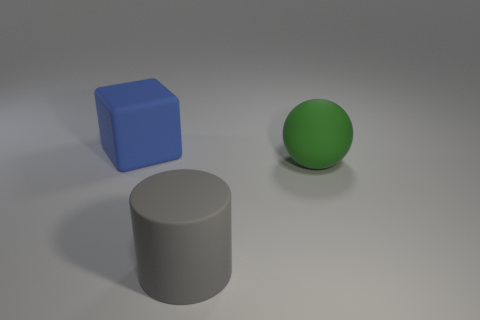Is there a gray matte object of the same size as the ball?
Offer a terse response. Yes. There is a large blue matte object; is it the same shape as the large rubber thing that is to the right of the big rubber cylinder?
Your response must be concise. No. How many balls are large gray matte things or blue matte things?
Keep it short and to the point. 0. What is the color of the rubber cylinder?
Make the answer very short. Gray. Is the number of blue rubber cubes greater than the number of big objects?
Your response must be concise. No. How many objects are either rubber things behind the green rubber object or big matte balls?
Your answer should be very brief. 2. Do the blue cube and the green object have the same material?
Provide a short and direct response. Yes. There is a matte thing on the right side of the large rubber cylinder; is its shape the same as the big object that is on the left side of the big gray matte thing?
Offer a very short reply. No. Does the rubber cylinder have the same size as the object on the right side of the big matte cylinder?
Your response must be concise. Yes. How many other objects are the same material as the big green ball?
Offer a very short reply. 2. 